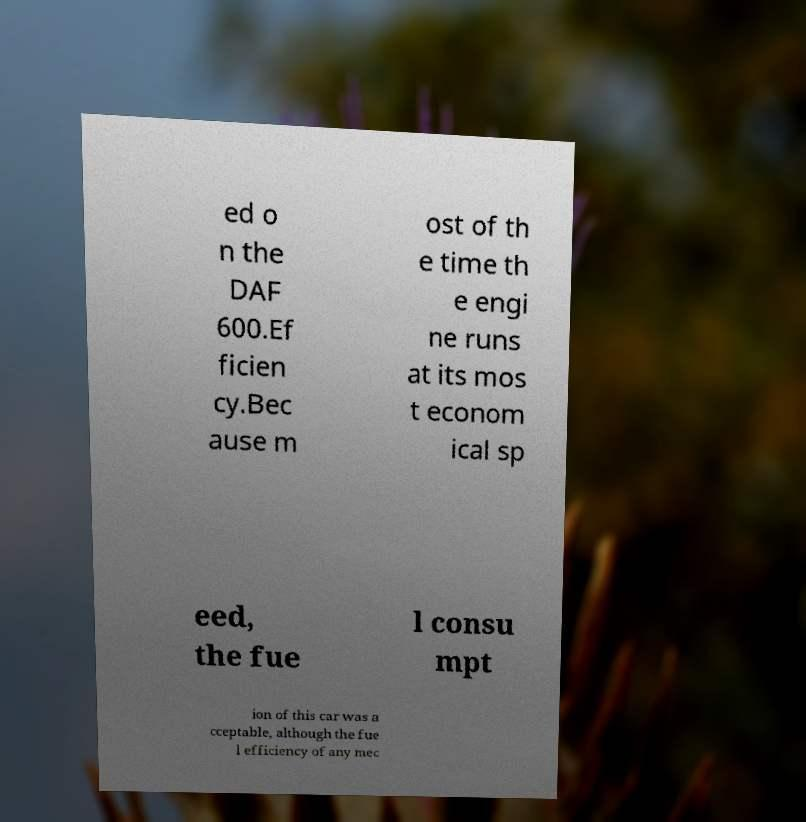Please identify and transcribe the text found in this image. ed o n the DAF 600.Ef ficien cy.Bec ause m ost of th e time th e engi ne runs at its mos t econom ical sp eed, the fue l consu mpt ion of this car was a cceptable, although the fue l efficiency of any mec 